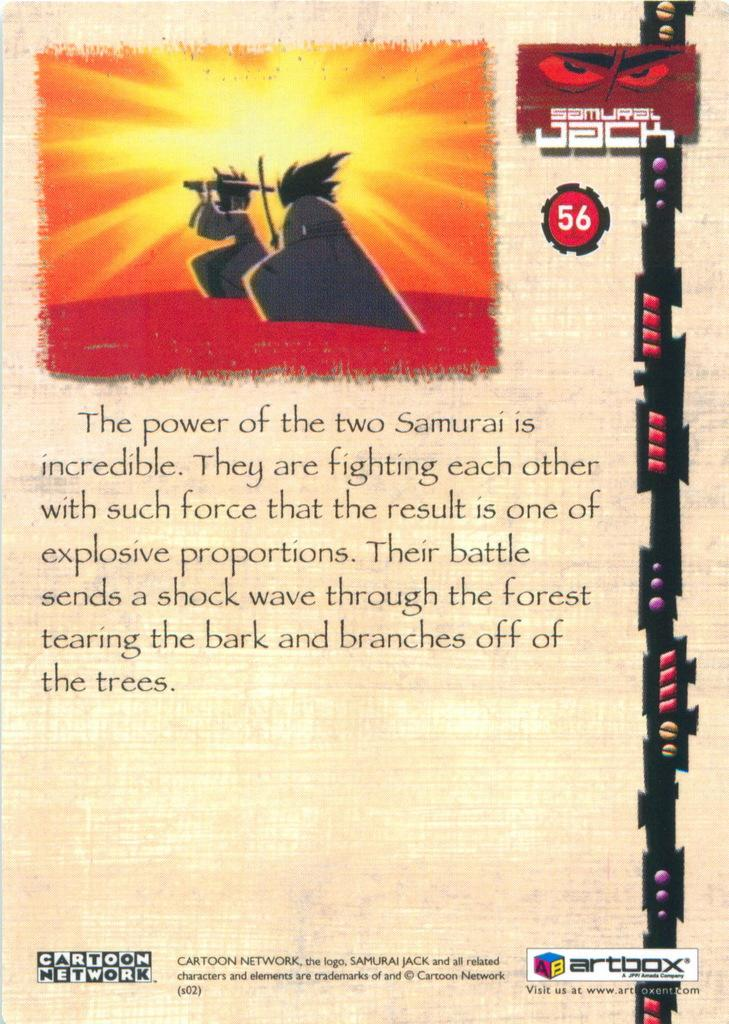<image>
Offer a succinct explanation of the picture presented. Two Samurai cartoon characters from the Samurai Jack series on Cartoon Network are shown along with information on this poster. 